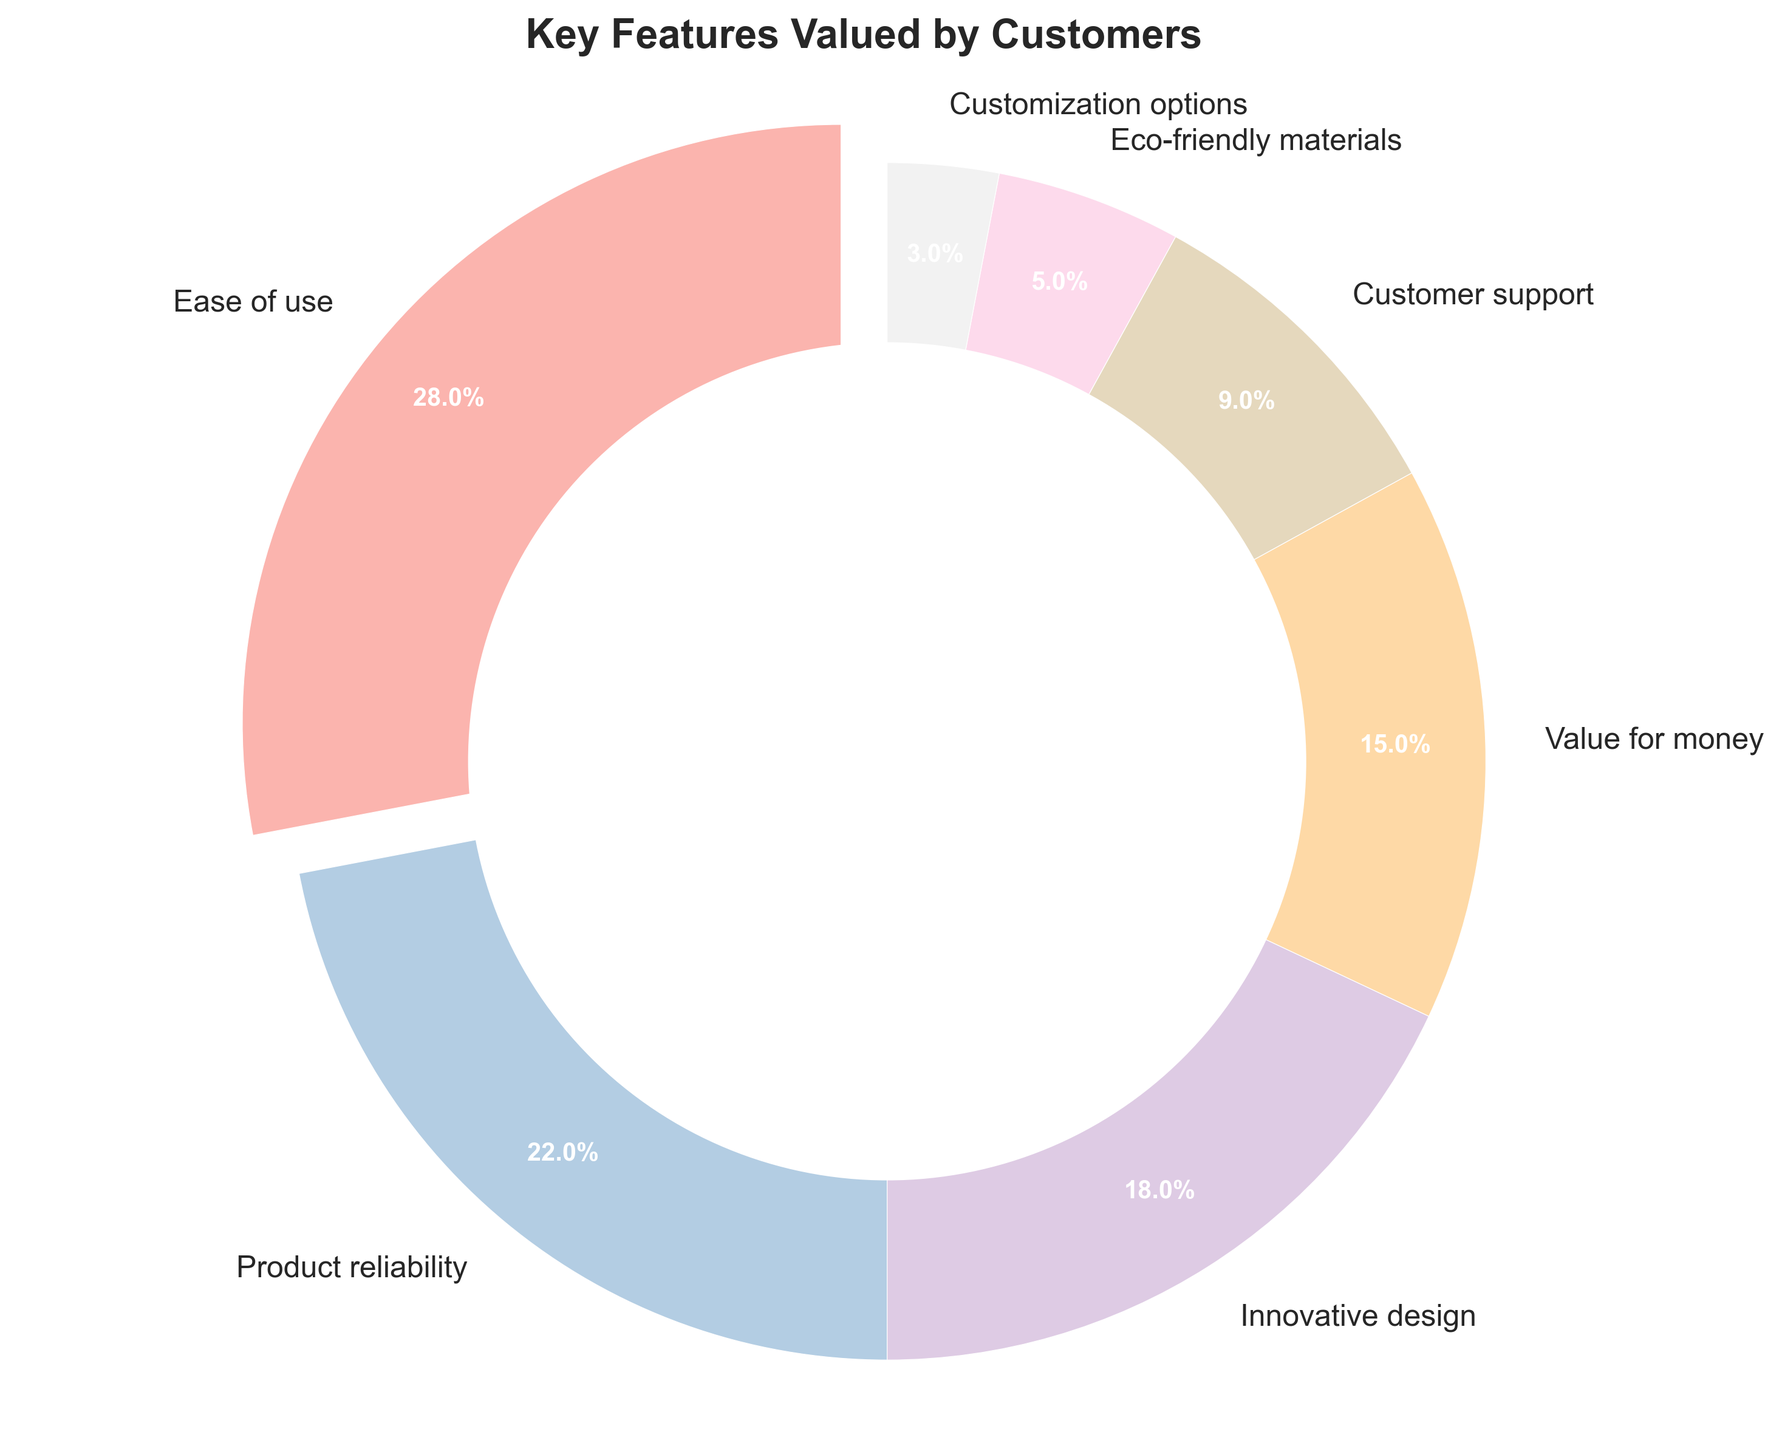What feature do customers value the most? The figure shows that 'Ease of use' has the largest percentage segment, which is indicated by the highest explosion in the pie chart.
Answer: Ease of use What is the combined percentage of 'Product reliability' and 'Value for money'? According to the pie chart, 'Product reliability' is 22% and 'Value for money' is 15%. Their combined percentage is 22 + 15 = 37%.
Answer: 37% Which feature is valued more: 'Customer support' or 'Innovative design'? The pie chart shows 'Innovative design' at 18% and 'Customer support' at 9%. Since 18% is greater than 9%, 'Innovative design' is valued more.
Answer: Innovative design What is the percentage difference between the most valued feature and the least valued feature? The most valued feature is 'Ease of use' at 28%, and the least valued is 'Customization options' at 3%. The difference is 28 - 3 = 25%.
Answer: 25% How does 'Eco-friendly materials' compare to the average value of all features? The average percentage is calculated by (28 + 22 + 18 + 15 + 9 + 5 + 3) / 7 = 100 / 7 ≈ 14.29%. 'Eco-friendly materials' is 5%, which is less than the average.
Answer: Less than the average Which feature occupies a larger segment: 'Eco-friendly materials' or 'Customization options'? The pie chart shows 'Eco-friendly materials' at 5% and 'Customization options' at 3%. Since 5% is greater than 3%, 'Eco-friendly materials' occupies a larger segment.
Answer: Eco-friendly materials Are there any features with a percentage greater than 20%? If yes, which ones? From the pie chart, 'Ease of use' at 28% and 'Product reliability' at 22% are both greater than 20%.
Answer: Ease of use, Product reliability What is the total percentage of features valued less than 10%? The features below 10% are 'Customer support' (9%), 'Eco-friendly materials' (5%), and 'Customization options' (3%). Their total percentage is 9 + 5 + 3 = 17%.
Answer: 17% Which feature has the smallest visual segment in the pie chart? The smallest visual segment in the pie chart is 'Customization options' at 3%, as indicated by its relatively smallest proportion compared to others.
Answer: Customization options What is the visual characteristic used to highlight the most valued feature? The most valued feature 'Ease of use' is highlighted by an exploded segment in the pie chart.
Answer: Exploded segment 